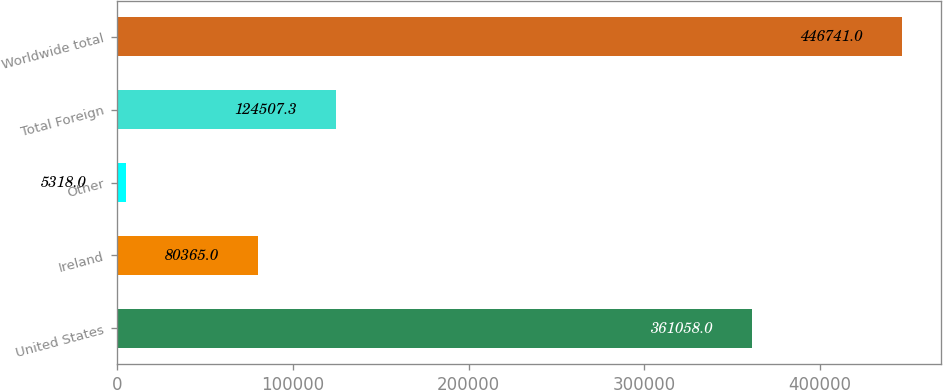Convert chart. <chart><loc_0><loc_0><loc_500><loc_500><bar_chart><fcel>United States<fcel>Ireland<fcel>Other<fcel>Total Foreign<fcel>Worldwide total<nl><fcel>361058<fcel>80365<fcel>5318<fcel>124507<fcel>446741<nl></chart> 